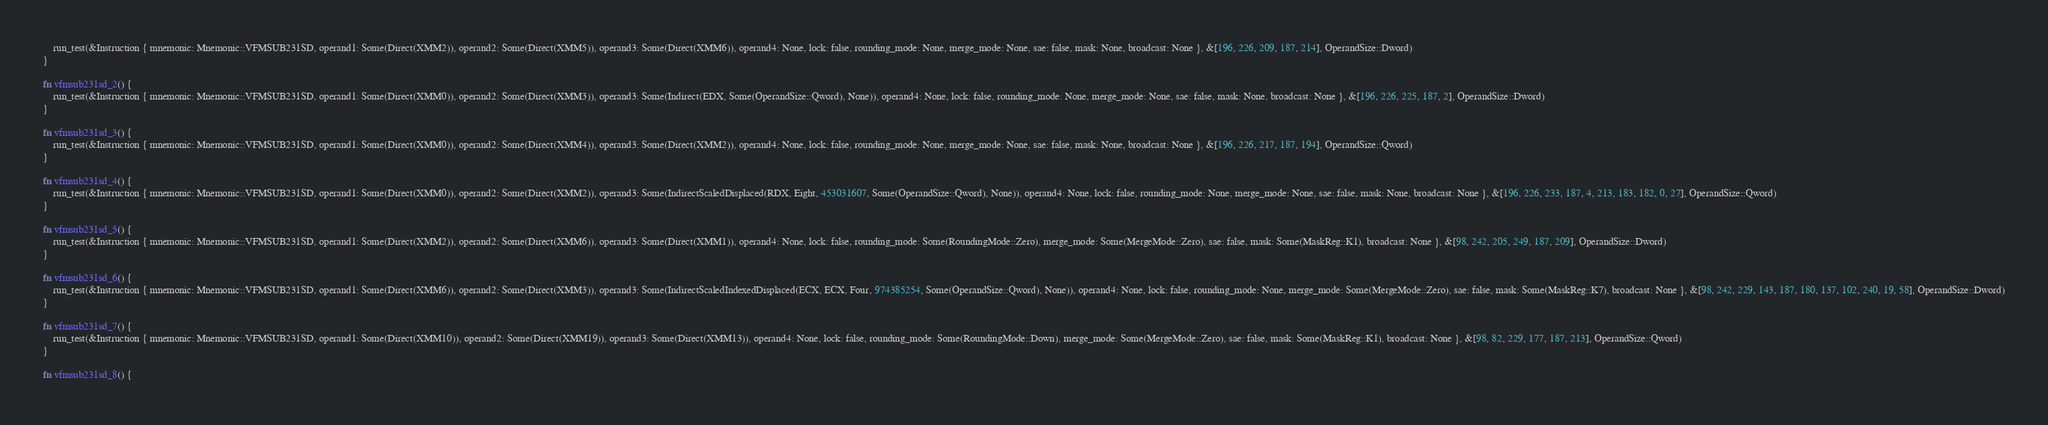Convert code to text. <code><loc_0><loc_0><loc_500><loc_500><_Rust_>    run_test(&Instruction { mnemonic: Mnemonic::VFMSUB231SD, operand1: Some(Direct(XMM2)), operand2: Some(Direct(XMM5)), operand3: Some(Direct(XMM6)), operand4: None, lock: false, rounding_mode: None, merge_mode: None, sae: false, mask: None, broadcast: None }, &[196, 226, 209, 187, 214], OperandSize::Dword)
}

fn vfmsub231sd_2() {
    run_test(&Instruction { mnemonic: Mnemonic::VFMSUB231SD, operand1: Some(Direct(XMM0)), operand2: Some(Direct(XMM3)), operand3: Some(Indirect(EDX, Some(OperandSize::Qword), None)), operand4: None, lock: false, rounding_mode: None, merge_mode: None, sae: false, mask: None, broadcast: None }, &[196, 226, 225, 187, 2], OperandSize::Dword)
}

fn vfmsub231sd_3() {
    run_test(&Instruction { mnemonic: Mnemonic::VFMSUB231SD, operand1: Some(Direct(XMM0)), operand2: Some(Direct(XMM4)), operand3: Some(Direct(XMM2)), operand4: None, lock: false, rounding_mode: None, merge_mode: None, sae: false, mask: None, broadcast: None }, &[196, 226, 217, 187, 194], OperandSize::Qword)
}

fn vfmsub231sd_4() {
    run_test(&Instruction { mnemonic: Mnemonic::VFMSUB231SD, operand1: Some(Direct(XMM0)), operand2: Some(Direct(XMM2)), operand3: Some(IndirectScaledDisplaced(RDX, Eight, 453031607, Some(OperandSize::Qword), None)), operand4: None, lock: false, rounding_mode: None, merge_mode: None, sae: false, mask: None, broadcast: None }, &[196, 226, 233, 187, 4, 213, 183, 182, 0, 27], OperandSize::Qword)
}

fn vfmsub231sd_5() {
    run_test(&Instruction { mnemonic: Mnemonic::VFMSUB231SD, operand1: Some(Direct(XMM2)), operand2: Some(Direct(XMM6)), operand3: Some(Direct(XMM1)), operand4: None, lock: false, rounding_mode: Some(RoundingMode::Zero), merge_mode: Some(MergeMode::Zero), sae: false, mask: Some(MaskReg::K1), broadcast: None }, &[98, 242, 205, 249, 187, 209], OperandSize::Dword)
}

fn vfmsub231sd_6() {
    run_test(&Instruction { mnemonic: Mnemonic::VFMSUB231SD, operand1: Some(Direct(XMM6)), operand2: Some(Direct(XMM3)), operand3: Some(IndirectScaledIndexedDisplaced(ECX, ECX, Four, 974385254, Some(OperandSize::Qword), None)), operand4: None, lock: false, rounding_mode: None, merge_mode: Some(MergeMode::Zero), sae: false, mask: Some(MaskReg::K7), broadcast: None }, &[98, 242, 229, 143, 187, 180, 137, 102, 240, 19, 58], OperandSize::Dword)
}

fn vfmsub231sd_7() {
    run_test(&Instruction { mnemonic: Mnemonic::VFMSUB231SD, operand1: Some(Direct(XMM10)), operand2: Some(Direct(XMM19)), operand3: Some(Direct(XMM13)), operand4: None, lock: false, rounding_mode: Some(RoundingMode::Down), merge_mode: Some(MergeMode::Zero), sae: false, mask: Some(MaskReg::K1), broadcast: None }, &[98, 82, 229, 177, 187, 213], OperandSize::Qword)
}

fn vfmsub231sd_8() {</code> 